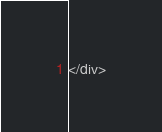Convert code to text. <code><loc_0><loc_0><loc_500><loc_500><_HTML_></div>
</code> 